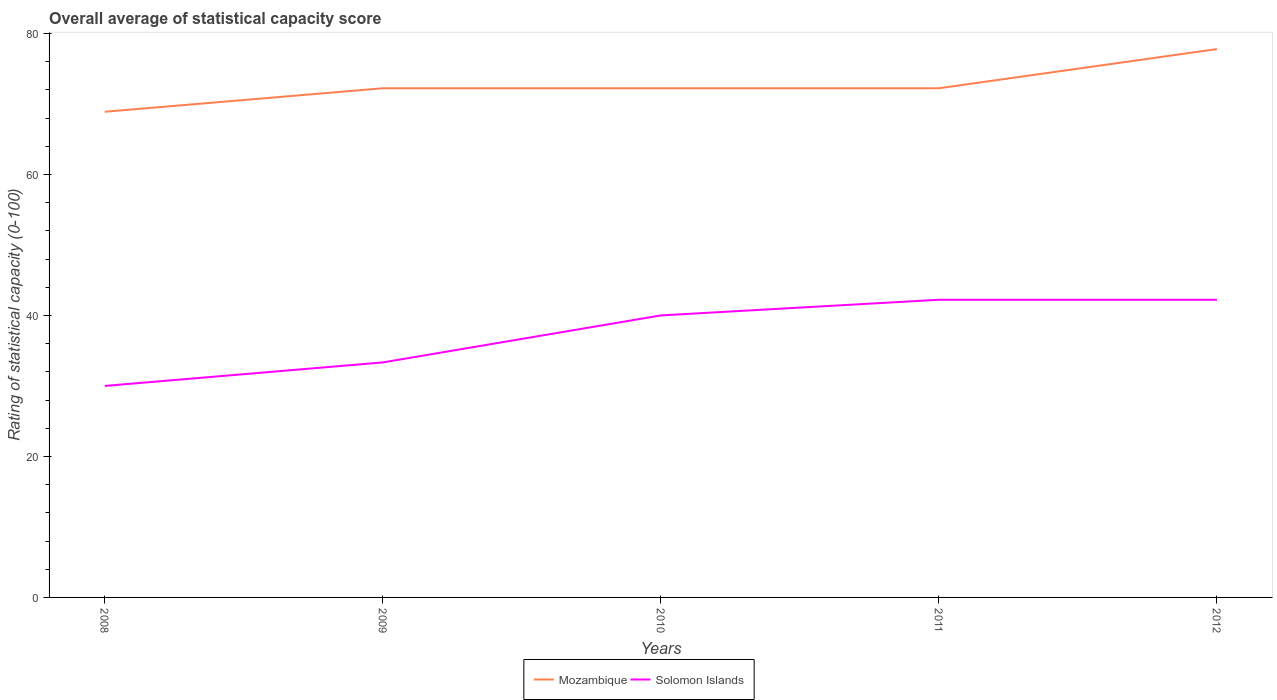How many different coloured lines are there?
Give a very brief answer. 2. Does the line corresponding to Mozambique intersect with the line corresponding to Solomon Islands?
Offer a terse response. No. Is the number of lines equal to the number of legend labels?
Offer a very short reply. Yes. Across all years, what is the maximum rating of statistical capacity in Mozambique?
Give a very brief answer. 68.89. What is the total rating of statistical capacity in Solomon Islands in the graph?
Offer a terse response. -2.22. What is the difference between the highest and the second highest rating of statistical capacity in Mozambique?
Your response must be concise. 8.89. What is the difference between the highest and the lowest rating of statistical capacity in Solomon Islands?
Provide a succinct answer. 3. Is the rating of statistical capacity in Solomon Islands strictly greater than the rating of statistical capacity in Mozambique over the years?
Provide a short and direct response. Yes. How many years are there in the graph?
Offer a terse response. 5. Are the values on the major ticks of Y-axis written in scientific E-notation?
Your answer should be compact. No. Where does the legend appear in the graph?
Your answer should be very brief. Bottom center. What is the title of the graph?
Ensure brevity in your answer.  Overall average of statistical capacity score. Does "Sao Tome and Principe" appear as one of the legend labels in the graph?
Provide a short and direct response. No. What is the label or title of the Y-axis?
Make the answer very short. Rating of statistical capacity (0-100). What is the Rating of statistical capacity (0-100) of Mozambique in 2008?
Offer a terse response. 68.89. What is the Rating of statistical capacity (0-100) of Solomon Islands in 2008?
Give a very brief answer. 30. What is the Rating of statistical capacity (0-100) in Mozambique in 2009?
Your answer should be compact. 72.22. What is the Rating of statistical capacity (0-100) in Solomon Islands in 2009?
Your answer should be compact. 33.33. What is the Rating of statistical capacity (0-100) of Mozambique in 2010?
Provide a succinct answer. 72.22. What is the Rating of statistical capacity (0-100) of Solomon Islands in 2010?
Keep it short and to the point. 40. What is the Rating of statistical capacity (0-100) in Mozambique in 2011?
Offer a terse response. 72.22. What is the Rating of statistical capacity (0-100) in Solomon Islands in 2011?
Give a very brief answer. 42.22. What is the Rating of statistical capacity (0-100) in Mozambique in 2012?
Give a very brief answer. 77.78. What is the Rating of statistical capacity (0-100) of Solomon Islands in 2012?
Offer a very short reply. 42.22. Across all years, what is the maximum Rating of statistical capacity (0-100) of Mozambique?
Your answer should be very brief. 77.78. Across all years, what is the maximum Rating of statistical capacity (0-100) of Solomon Islands?
Provide a short and direct response. 42.22. Across all years, what is the minimum Rating of statistical capacity (0-100) in Mozambique?
Your answer should be compact. 68.89. What is the total Rating of statistical capacity (0-100) of Mozambique in the graph?
Offer a terse response. 363.33. What is the total Rating of statistical capacity (0-100) of Solomon Islands in the graph?
Your answer should be compact. 187.78. What is the difference between the Rating of statistical capacity (0-100) of Solomon Islands in 2008 and that in 2009?
Your answer should be compact. -3.33. What is the difference between the Rating of statistical capacity (0-100) of Solomon Islands in 2008 and that in 2010?
Give a very brief answer. -10. What is the difference between the Rating of statistical capacity (0-100) of Mozambique in 2008 and that in 2011?
Give a very brief answer. -3.33. What is the difference between the Rating of statistical capacity (0-100) in Solomon Islands in 2008 and that in 2011?
Provide a succinct answer. -12.22. What is the difference between the Rating of statistical capacity (0-100) in Mozambique in 2008 and that in 2012?
Your answer should be very brief. -8.89. What is the difference between the Rating of statistical capacity (0-100) in Solomon Islands in 2008 and that in 2012?
Your answer should be compact. -12.22. What is the difference between the Rating of statistical capacity (0-100) in Mozambique in 2009 and that in 2010?
Your answer should be very brief. 0. What is the difference between the Rating of statistical capacity (0-100) of Solomon Islands in 2009 and that in 2010?
Provide a short and direct response. -6.67. What is the difference between the Rating of statistical capacity (0-100) of Solomon Islands in 2009 and that in 2011?
Provide a short and direct response. -8.89. What is the difference between the Rating of statistical capacity (0-100) of Mozambique in 2009 and that in 2012?
Make the answer very short. -5.56. What is the difference between the Rating of statistical capacity (0-100) of Solomon Islands in 2009 and that in 2012?
Your answer should be compact. -8.89. What is the difference between the Rating of statistical capacity (0-100) in Solomon Islands in 2010 and that in 2011?
Provide a short and direct response. -2.22. What is the difference between the Rating of statistical capacity (0-100) of Mozambique in 2010 and that in 2012?
Provide a short and direct response. -5.56. What is the difference between the Rating of statistical capacity (0-100) in Solomon Islands in 2010 and that in 2012?
Your response must be concise. -2.22. What is the difference between the Rating of statistical capacity (0-100) in Mozambique in 2011 and that in 2012?
Your response must be concise. -5.56. What is the difference between the Rating of statistical capacity (0-100) of Solomon Islands in 2011 and that in 2012?
Offer a terse response. 0. What is the difference between the Rating of statistical capacity (0-100) of Mozambique in 2008 and the Rating of statistical capacity (0-100) of Solomon Islands in 2009?
Ensure brevity in your answer.  35.56. What is the difference between the Rating of statistical capacity (0-100) of Mozambique in 2008 and the Rating of statistical capacity (0-100) of Solomon Islands in 2010?
Your response must be concise. 28.89. What is the difference between the Rating of statistical capacity (0-100) in Mozambique in 2008 and the Rating of statistical capacity (0-100) in Solomon Islands in 2011?
Your response must be concise. 26.67. What is the difference between the Rating of statistical capacity (0-100) of Mozambique in 2008 and the Rating of statistical capacity (0-100) of Solomon Islands in 2012?
Offer a very short reply. 26.67. What is the difference between the Rating of statistical capacity (0-100) of Mozambique in 2009 and the Rating of statistical capacity (0-100) of Solomon Islands in 2010?
Offer a very short reply. 32.22. What is the difference between the Rating of statistical capacity (0-100) in Mozambique in 2009 and the Rating of statistical capacity (0-100) in Solomon Islands in 2012?
Offer a terse response. 30. What is the difference between the Rating of statistical capacity (0-100) of Mozambique in 2010 and the Rating of statistical capacity (0-100) of Solomon Islands in 2011?
Make the answer very short. 30. What is the difference between the Rating of statistical capacity (0-100) in Mozambique in 2011 and the Rating of statistical capacity (0-100) in Solomon Islands in 2012?
Your answer should be very brief. 30. What is the average Rating of statistical capacity (0-100) of Mozambique per year?
Offer a very short reply. 72.67. What is the average Rating of statistical capacity (0-100) of Solomon Islands per year?
Make the answer very short. 37.56. In the year 2008, what is the difference between the Rating of statistical capacity (0-100) in Mozambique and Rating of statistical capacity (0-100) in Solomon Islands?
Keep it short and to the point. 38.89. In the year 2009, what is the difference between the Rating of statistical capacity (0-100) of Mozambique and Rating of statistical capacity (0-100) of Solomon Islands?
Provide a succinct answer. 38.89. In the year 2010, what is the difference between the Rating of statistical capacity (0-100) of Mozambique and Rating of statistical capacity (0-100) of Solomon Islands?
Make the answer very short. 32.22. In the year 2011, what is the difference between the Rating of statistical capacity (0-100) of Mozambique and Rating of statistical capacity (0-100) of Solomon Islands?
Offer a very short reply. 30. In the year 2012, what is the difference between the Rating of statistical capacity (0-100) of Mozambique and Rating of statistical capacity (0-100) of Solomon Islands?
Your answer should be compact. 35.56. What is the ratio of the Rating of statistical capacity (0-100) of Mozambique in 2008 to that in 2009?
Provide a succinct answer. 0.95. What is the ratio of the Rating of statistical capacity (0-100) in Solomon Islands in 2008 to that in 2009?
Provide a succinct answer. 0.9. What is the ratio of the Rating of statistical capacity (0-100) in Mozambique in 2008 to that in 2010?
Your answer should be compact. 0.95. What is the ratio of the Rating of statistical capacity (0-100) of Mozambique in 2008 to that in 2011?
Keep it short and to the point. 0.95. What is the ratio of the Rating of statistical capacity (0-100) of Solomon Islands in 2008 to that in 2011?
Make the answer very short. 0.71. What is the ratio of the Rating of statistical capacity (0-100) of Mozambique in 2008 to that in 2012?
Your answer should be compact. 0.89. What is the ratio of the Rating of statistical capacity (0-100) in Solomon Islands in 2008 to that in 2012?
Give a very brief answer. 0.71. What is the ratio of the Rating of statistical capacity (0-100) in Mozambique in 2009 to that in 2010?
Provide a short and direct response. 1. What is the ratio of the Rating of statistical capacity (0-100) of Solomon Islands in 2009 to that in 2010?
Ensure brevity in your answer.  0.83. What is the ratio of the Rating of statistical capacity (0-100) in Mozambique in 2009 to that in 2011?
Give a very brief answer. 1. What is the ratio of the Rating of statistical capacity (0-100) in Solomon Islands in 2009 to that in 2011?
Offer a terse response. 0.79. What is the ratio of the Rating of statistical capacity (0-100) in Mozambique in 2009 to that in 2012?
Your response must be concise. 0.93. What is the ratio of the Rating of statistical capacity (0-100) of Solomon Islands in 2009 to that in 2012?
Provide a short and direct response. 0.79. What is the ratio of the Rating of statistical capacity (0-100) of Mozambique in 2010 to that in 2011?
Your answer should be compact. 1. What is the ratio of the Rating of statistical capacity (0-100) of Mozambique in 2010 to that in 2012?
Give a very brief answer. 0.93. What is the ratio of the Rating of statistical capacity (0-100) in Mozambique in 2011 to that in 2012?
Offer a very short reply. 0.93. What is the ratio of the Rating of statistical capacity (0-100) of Solomon Islands in 2011 to that in 2012?
Offer a very short reply. 1. What is the difference between the highest and the second highest Rating of statistical capacity (0-100) in Mozambique?
Give a very brief answer. 5.56. What is the difference between the highest and the second highest Rating of statistical capacity (0-100) in Solomon Islands?
Make the answer very short. 0. What is the difference between the highest and the lowest Rating of statistical capacity (0-100) of Mozambique?
Your answer should be compact. 8.89. What is the difference between the highest and the lowest Rating of statistical capacity (0-100) in Solomon Islands?
Give a very brief answer. 12.22. 